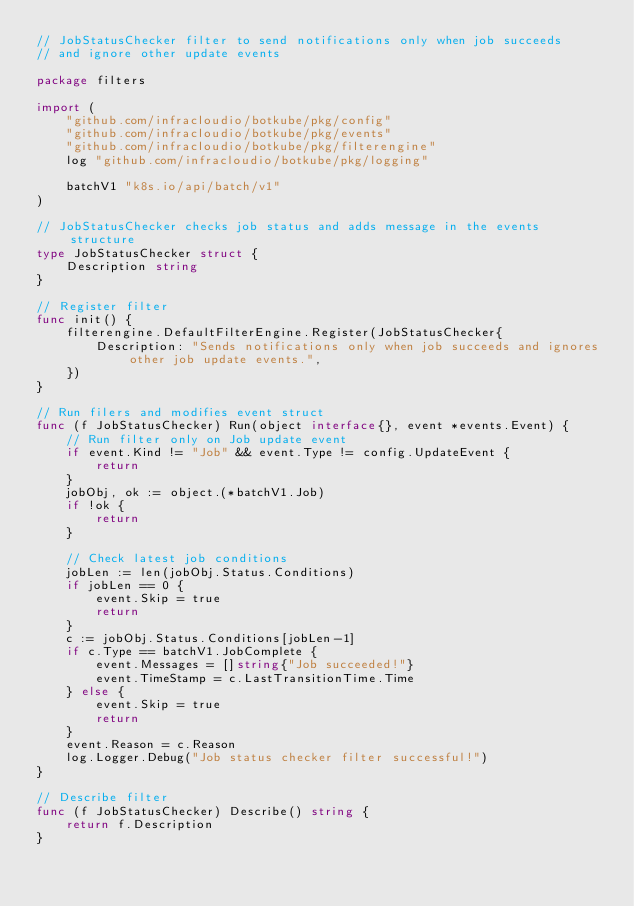Convert code to text. <code><loc_0><loc_0><loc_500><loc_500><_Go_>// JobStatusChecker filter to send notifications only when job succeeds
// and ignore other update events

package filters

import (
	"github.com/infracloudio/botkube/pkg/config"
	"github.com/infracloudio/botkube/pkg/events"
	"github.com/infracloudio/botkube/pkg/filterengine"
	log "github.com/infracloudio/botkube/pkg/logging"

	batchV1 "k8s.io/api/batch/v1"
)

// JobStatusChecker checks job status and adds message in the events structure
type JobStatusChecker struct {
	Description string
}

// Register filter
func init() {
	filterengine.DefaultFilterEngine.Register(JobStatusChecker{
		Description: "Sends notifications only when job succeeds and ignores other job update events.",
	})
}

// Run filers and modifies event struct
func (f JobStatusChecker) Run(object interface{}, event *events.Event) {
	// Run filter only on Job update event
	if event.Kind != "Job" && event.Type != config.UpdateEvent {
		return
	}
	jobObj, ok := object.(*batchV1.Job)
	if !ok {
		return
	}

	// Check latest job conditions
	jobLen := len(jobObj.Status.Conditions)
	if jobLen == 0 {
		event.Skip = true
		return
	}
	c := jobObj.Status.Conditions[jobLen-1]
	if c.Type == batchV1.JobComplete {
		event.Messages = []string{"Job succeeded!"}
		event.TimeStamp = c.LastTransitionTime.Time
	} else {
		event.Skip = true
		return
	}
	event.Reason = c.Reason
	log.Logger.Debug("Job status checker filter successful!")
}

// Describe filter
func (f JobStatusChecker) Describe() string {
	return f.Description
}
</code> 